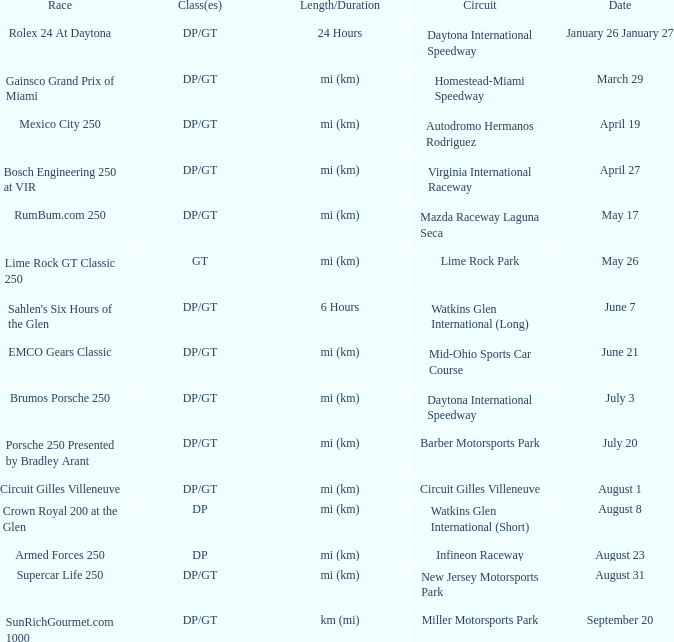What is the date of the event featuring a race that lasted for 6 hours? June 7. 